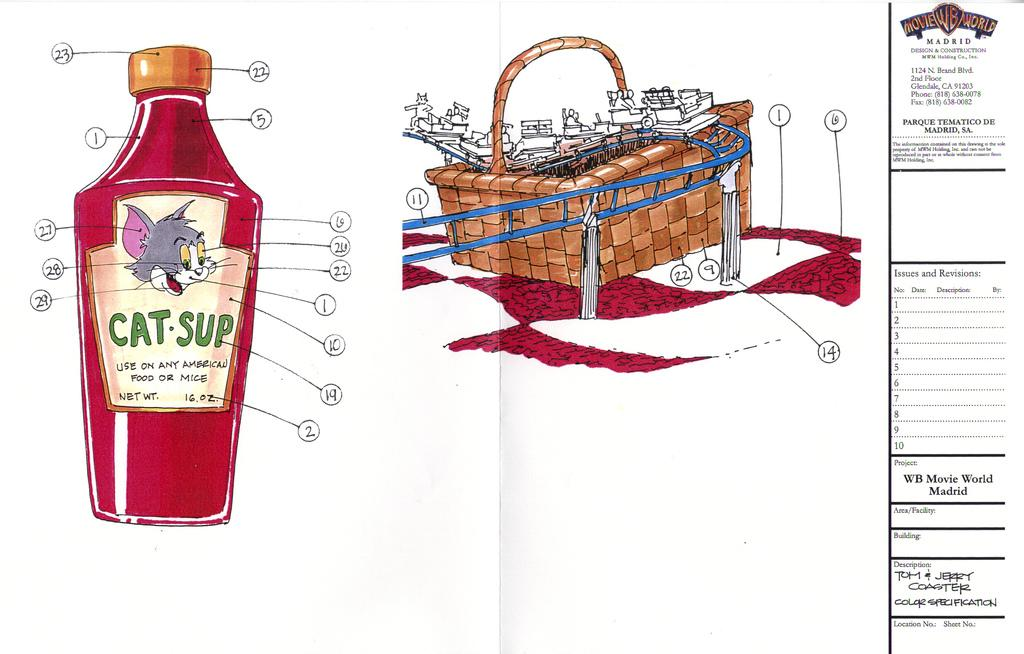<image>
Write a terse but informative summary of the picture. A drawing of a Warner Brothers cartoon is on a cat-sup label. 